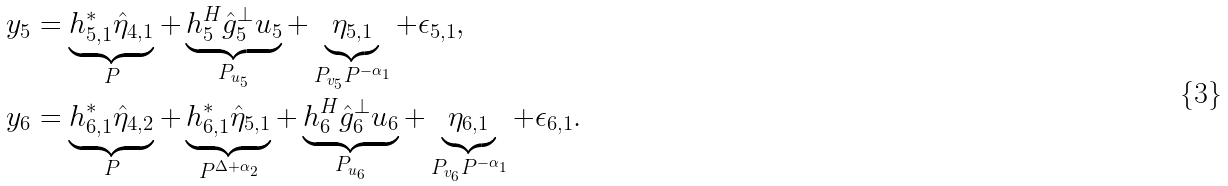<formula> <loc_0><loc_0><loc_500><loc_500>y _ { 5 } & = \underbrace { h _ { 5 , 1 } ^ { * } \hat { \eta } _ { 4 , 1 } } _ { P } + \underbrace { h _ { 5 } ^ { H } \hat { g } _ { 5 } ^ { \bot } u _ { 5 } } _ { P _ { u _ { 5 } } } + \underbrace { \eta _ { 5 , 1 } } _ { P _ { v _ { 5 } } P ^ { - \alpha _ { 1 } } } + \epsilon _ { 5 , 1 } , \\ y _ { 6 } & = \underbrace { h _ { 6 , 1 } ^ { * } \hat { \eta } _ { 4 , 2 } } _ { P } + \underbrace { h _ { 6 , 1 } ^ { * } \hat { \eta } _ { 5 , 1 } } _ { P ^ { \Delta + \alpha _ { 2 } } } + \underbrace { h _ { 6 } ^ { H } \hat { g } _ { 6 } ^ { \bot } u _ { 6 } } _ { P _ { u _ { 6 } } } + \underbrace { \eta _ { 6 , 1 } } _ { P _ { v _ { 6 } } P ^ { - \alpha _ { 1 } } } + \epsilon _ { 6 , 1 } .</formula> 